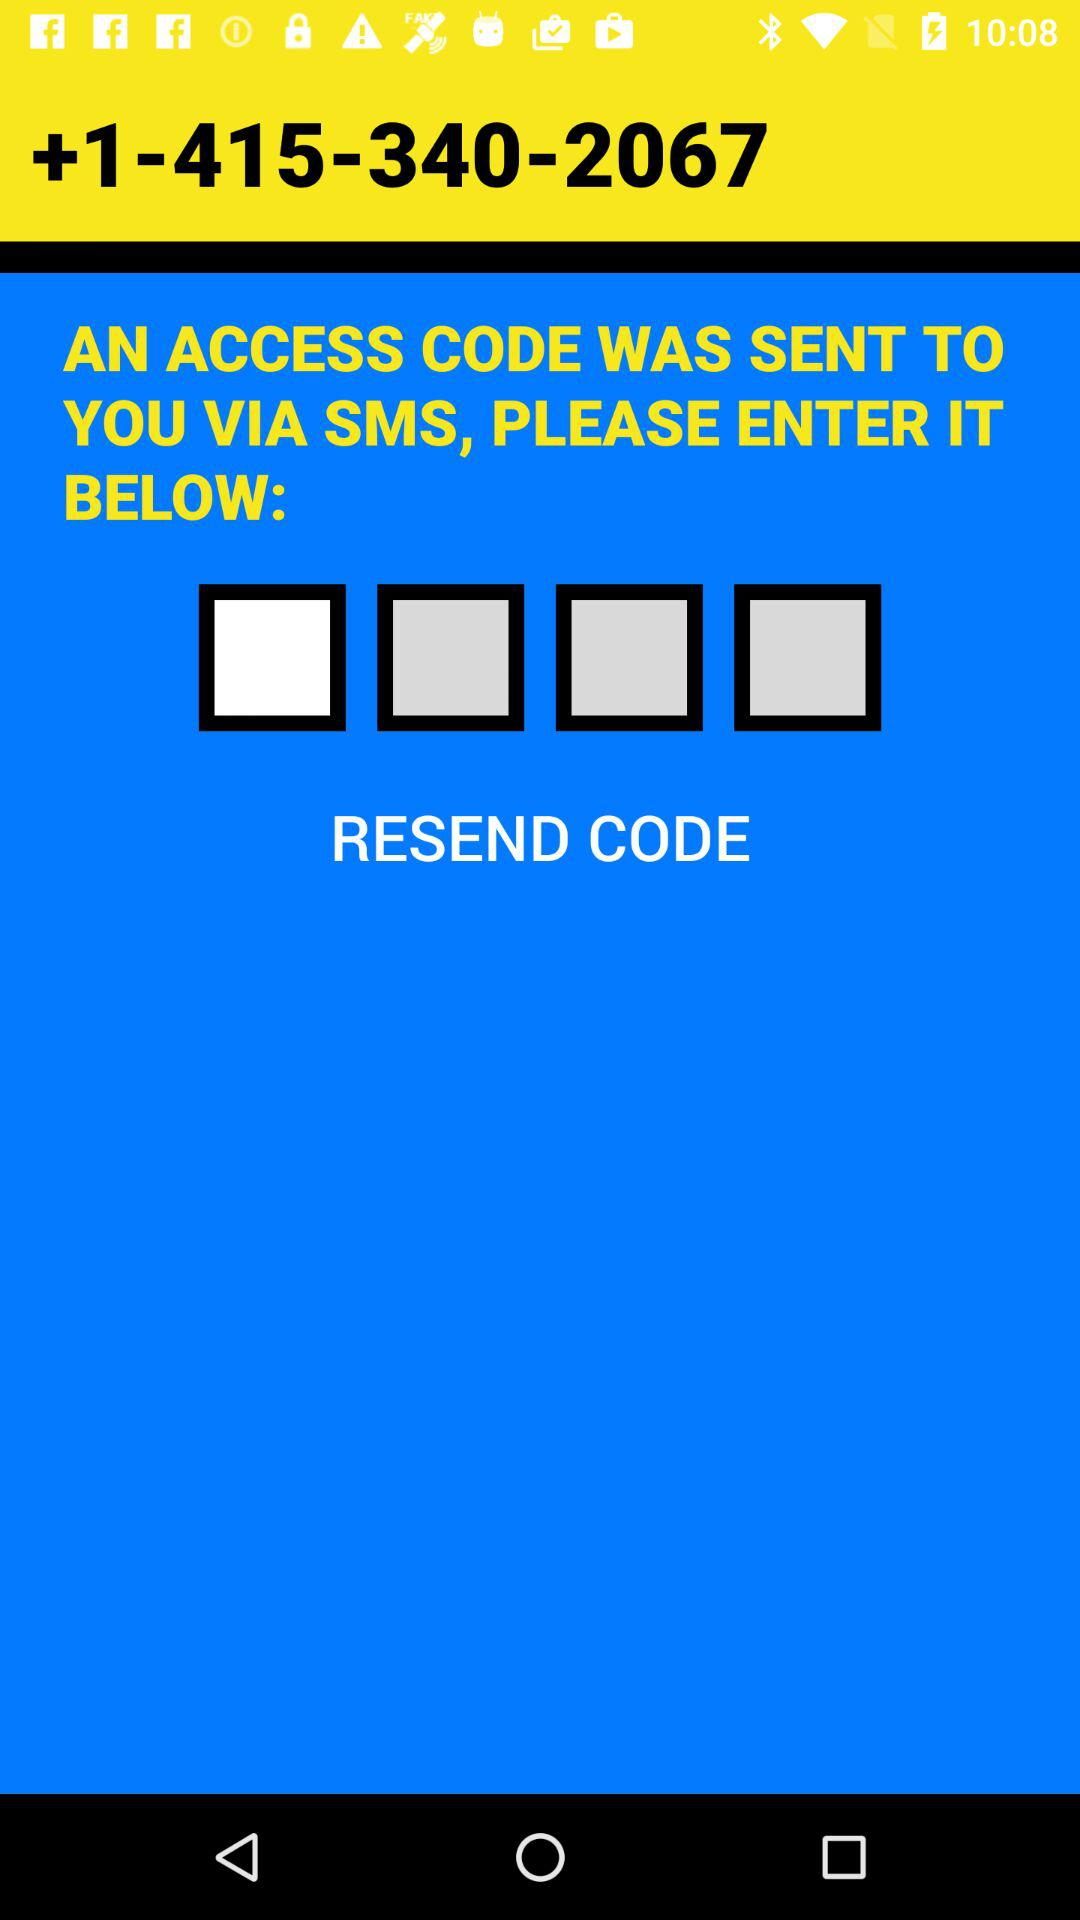How was the code sent? The code was sent via SMS. 